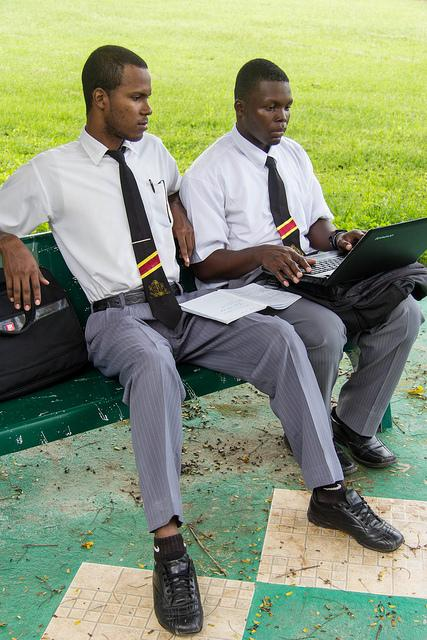What do the men's uniforms typically represent? Please explain your reasoning. school. Higher end schools require students to wear uniforms. 